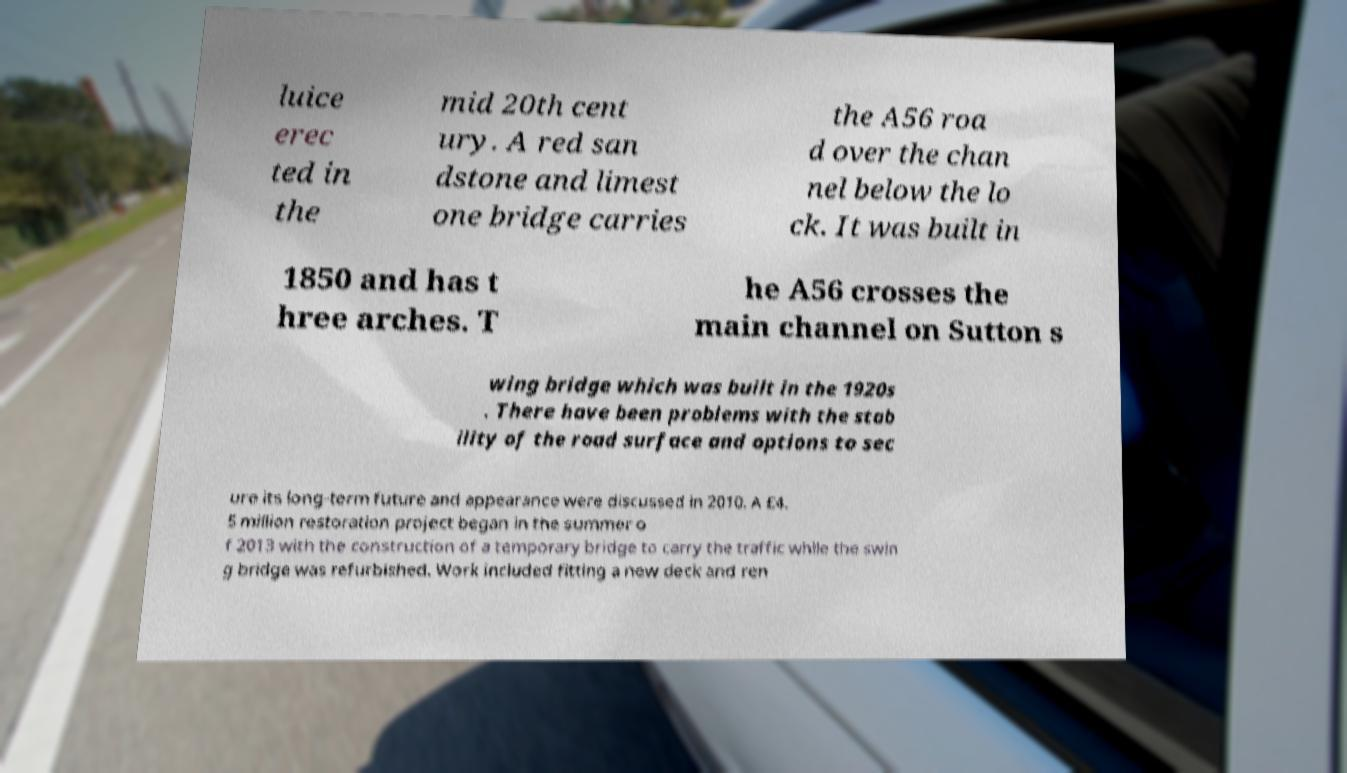I need the written content from this picture converted into text. Can you do that? luice erec ted in the mid 20th cent ury. A red san dstone and limest one bridge carries the A56 roa d over the chan nel below the lo ck. It was built in 1850 and has t hree arches. T he A56 crosses the main channel on Sutton s wing bridge which was built in the 1920s . There have been problems with the stab ility of the road surface and options to sec ure its long-term future and appearance were discussed in 2010. A £4. 5 million restoration project began in the summer o f 2013 with the construction of a temporary bridge to carry the traffic while the swin g bridge was refurbished. Work included fitting a new deck and ren 